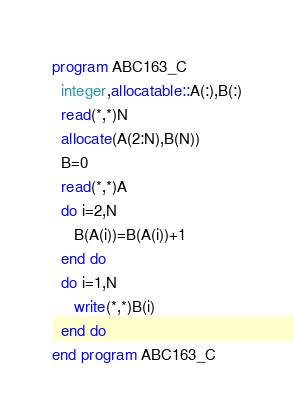Convert code to text. <code><loc_0><loc_0><loc_500><loc_500><_FORTRAN_>program ABC163_C
  integer,allocatable::A(:),B(:)
  read(*,*)N
  allocate(A(2:N),B(N))
  B=0
  read(*,*)A
  do i=2,N
     B(A(i))=B(A(i))+1
  end do
  do i=1,N
     write(*,*)B(i)
  end do
end program ABC163_C</code> 